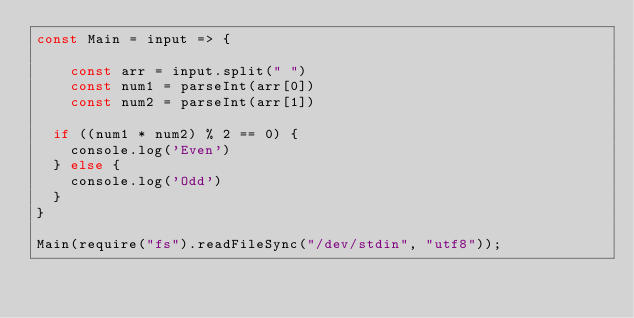<code> <loc_0><loc_0><loc_500><loc_500><_JavaScript_>const Main = input => {
  
    const arr = input.split(" ")
    const num1 = parseInt(arr[0])
    const num2 = parseInt(arr[1])
  
  if ((num1 * num2) % 2 == 0) {
  	console.log('Even')
  } else {
    console.log('Odd')
  }
}
 
Main(require("fs").readFileSync("/dev/stdin", "utf8"));</code> 